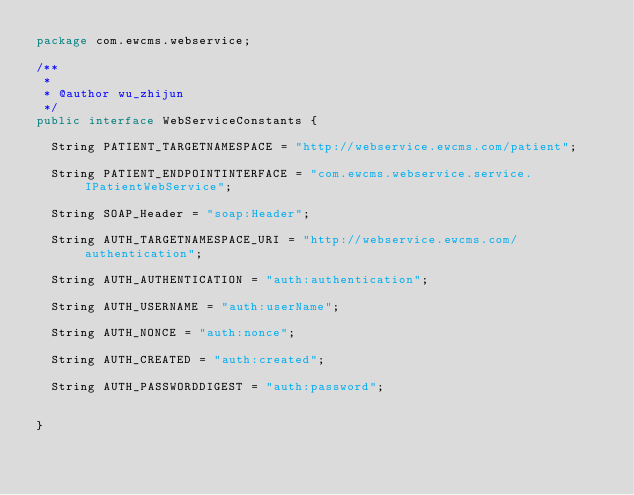<code> <loc_0><loc_0><loc_500><loc_500><_Java_>package com.ewcms.webservice;

/**
 *
 * @author wu_zhijun
 */
public interface WebServiceConstants {
	
	String PATIENT_TARGETNAMESPACE = "http://webservice.ewcms.com/patient";
	
	String PATIENT_ENDPOINTINTERFACE = "com.ewcms.webservice.service.IPatientWebService";

	String SOAP_Header = "soap:Header";
	
	String AUTH_TARGETNAMESPACE_URI = "http://webservice.ewcms.com/authentication";
	
	String AUTH_AUTHENTICATION = "auth:authentication";
	
	String AUTH_USERNAME = "auth:userName";
	
	String AUTH_NONCE = "auth:nonce";
	
	String AUTH_CREATED = "auth:created";
	
	String AUTH_PASSWORDDIGEST = "auth:password";
	
	
}
</code> 